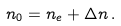Convert formula to latex. <formula><loc_0><loc_0><loc_500><loc_500>n _ { 0 } = n _ { e } + \Delta n \, .</formula> 